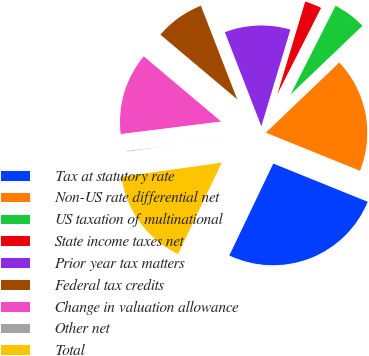Convert chart. <chart><loc_0><loc_0><loc_500><loc_500><pie_chart><fcel>Tax at statutory rate<fcel>Non-US rate differential net<fcel>US taxation of multinational<fcel>State income taxes net<fcel>Prior year tax matters<fcel>Federal tax credits<fcel>Change in valuation allowance<fcel>Other net<fcel>Total<nl><fcel>25.98%<fcel>18.26%<fcel>5.39%<fcel>2.82%<fcel>10.54%<fcel>7.97%<fcel>13.11%<fcel>0.24%<fcel>15.69%<nl></chart> 